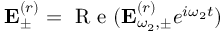<formula> <loc_0><loc_0><loc_500><loc_500>{ E } _ { \pm } ^ { ( r ) } = R e ( { E } _ { \omega _ { 2 } , \pm } ^ { ( r ) } e ^ { i \omega _ { 2 } t } )</formula> 